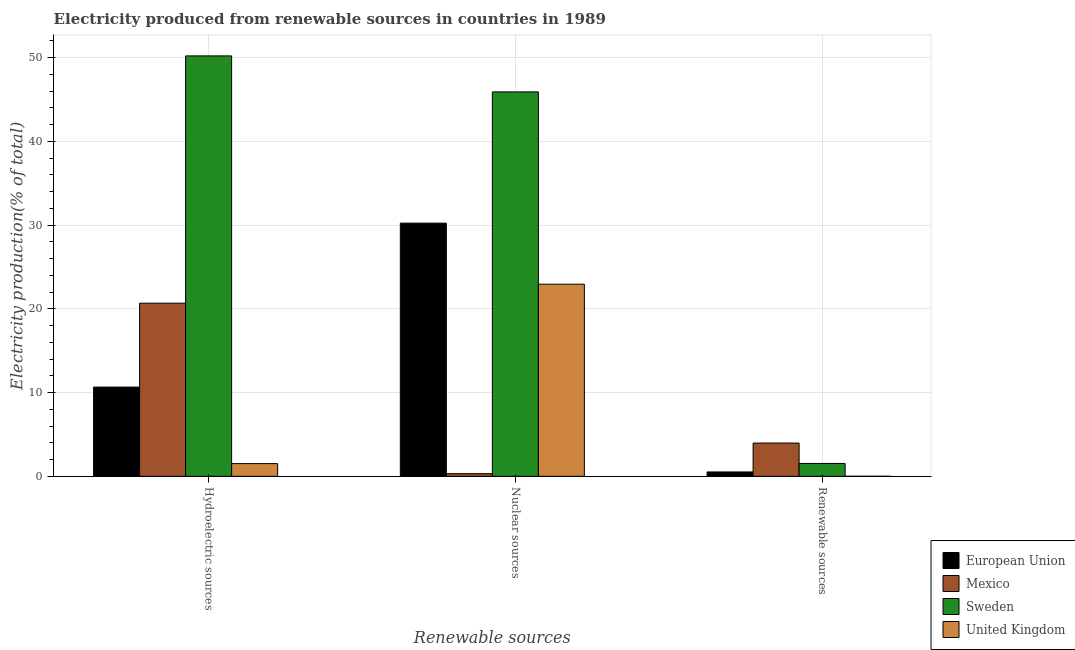How many groups of bars are there?
Provide a succinct answer. 3. Are the number of bars per tick equal to the number of legend labels?
Your answer should be very brief. Yes. Are the number of bars on each tick of the X-axis equal?
Ensure brevity in your answer.  Yes. How many bars are there on the 2nd tick from the right?
Give a very brief answer. 4. What is the label of the 3rd group of bars from the left?
Make the answer very short. Renewable sources. What is the percentage of electricity produced by hydroelectric sources in Sweden?
Give a very brief answer. 50.2. Across all countries, what is the maximum percentage of electricity produced by hydroelectric sources?
Your response must be concise. 50.2. Across all countries, what is the minimum percentage of electricity produced by renewable sources?
Give a very brief answer. 0. In which country was the percentage of electricity produced by hydroelectric sources minimum?
Your response must be concise. United Kingdom. What is the total percentage of electricity produced by renewable sources in the graph?
Your response must be concise. 6.03. What is the difference between the percentage of electricity produced by hydroelectric sources in Sweden and that in United Kingdom?
Your response must be concise. 48.68. What is the difference between the percentage of electricity produced by renewable sources in Sweden and the percentage of electricity produced by hydroelectric sources in Mexico?
Your answer should be compact. -19.14. What is the average percentage of electricity produced by hydroelectric sources per country?
Provide a succinct answer. 20.76. What is the difference between the percentage of electricity produced by nuclear sources and percentage of electricity produced by hydroelectric sources in Mexico?
Provide a succinct answer. -20.36. In how many countries, is the percentage of electricity produced by nuclear sources greater than 6 %?
Make the answer very short. 3. What is the ratio of the percentage of electricity produced by renewable sources in Mexico to that in European Union?
Offer a very short reply. 7.61. What is the difference between the highest and the second highest percentage of electricity produced by hydroelectric sources?
Make the answer very short. 29.53. What is the difference between the highest and the lowest percentage of electricity produced by hydroelectric sources?
Offer a very short reply. 48.68. In how many countries, is the percentage of electricity produced by hydroelectric sources greater than the average percentage of electricity produced by hydroelectric sources taken over all countries?
Your answer should be compact. 1. Is the sum of the percentage of electricity produced by hydroelectric sources in Sweden and Mexico greater than the maximum percentage of electricity produced by nuclear sources across all countries?
Your answer should be compact. Yes. Is it the case that in every country, the sum of the percentage of electricity produced by hydroelectric sources and percentage of electricity produced by nuclear sources is greater than the percentage of electricity produced by renewable sources?
Offer a very short reply. Yes. How many bars are there?
Your response must be concise. 12. How many countries are there in the graph?
Offer a very short reply. 4. What is the difference between two consecutive major ticks on the Y-axis?
Your answer should be very brief. 10. Are the values on the major ticks of Y-axis written in scientific E-notation?
Offer a very short reply. No. Does the graph contain any zero values?
Your response must be concise. No. Does the graph contain grids?
Your answer should be very brief. Yes. How are the legend labels stacked?
Provide a succinct answer. Vertical. What is the title of the graph?
Your answer should be very brief. Electricity produced from renewable sources in countries in 1989. Does "Rwanda" appear as one of the legend labels in the graph?
Your response must be concise. No. What is the label or title of the X-axis?
Keep it short and to the point. Renewable sources. What is the label or title of the Y-axis?
Ensure brevity in your answer.  Electricity production(% of total). What is the Electricity production(% of total) of European Union in Hydroelectric sources?
Provide a succinct answer. 10.66. What is the Electricity production(% of total) in Mexico in Hydroelectric sources?
Make the answer very short. 20.67. What is the Electricity production(% of total) in Sweden in Hydroelectric sources?
Provide a succinct answer. 50.2. What is the Electricity production(% of total) of United Kingdom in Hydroelectric sources?
Make the answer very short. 1.52. What is the Electricity production(% of total) in European Union in Nuclear sources?
Your answer should be very brief. 30.23. What is the Electricity production(% of total) in Mexico in Nuclear sources?
Your answer should be compact. 0.32. What is the Electricity production(% of total) of Sweden in Nuclear sources?
Provide a succinct answer. 45.9. What is the Electricity production(% of total) in United Kingdom in Nuclear sources?
Ensure brevity in your answer.  22.94. What is the Electricity production(% of total) of European Union in Renewable sources?
Your response must be concise. 0.52. What is the Electricity production(% of total) of Mexico in Renewable sources?
Your answer should be very brief. 3.97. What is the Electricity production(% of total) of Sweden in Renewable sources?
Give a very brief answer. 1.54. What is the Electricity production(% of total) of United Kingdom in Renewable sources?
Your answer should be very brief. 0. Across all Renewable sources, what is the maximum Electricity production(% of total) in European Union?
Ensure brevity in your answer.  30.23. Across all Renewable sources, what is the maximum Electricity production(% of total) in Mexico?
Offer a very short reply. 20.67. Across all Renewable sources, what is the maximum Electricity production(% of total) in Sweden?
Make the answer very short. 50.2. Across all Renewable sources, what is the maximum Electricity production(% of total) in United Kingdom?
Your answer should be compact. 22.94. Across all Renewable sources, what is the minimum Electricity production(% of total) in European Union?
Make the answer very short. 0.52. Across all Renewable sources, what is the minimum Electricity production(% of total) in Mexico?
Give a very brief answer. 0.32. Across all Renewable sources, what is the minimum Electricity production(% of total) in Sweden?
Provide a short and direct response. 1.54. Across all Renewable sources, what is the minimum Electricity production(% of total) of United Kingdom?
Give a very brief answer. 0. What is the total Electricity production(% of total) in European Union in the graph?
Provide a short and direct response. 41.41. What is the total Electricity production(% of total) in Mexico in the graph?
Give a very brief answer. 24.96. What is the total Electricity production(% of total) of Sweden in the graph?
Ensure brevity in your answer.  97.64. What is the total Electricity production(% of total) in United Kingdom in the graph?
Your answer should be very brief. 24.46. What is the difference between the Electricity production(% of total) of European Union in Hydroelectric sources and that in Nuclear sources?
Provide a short and direct response. -19.58. What is the difference between the Electricity production(% of total) in Mexico in Hydroelectric sources and that in Nuclear sources?
Offer a very short reply. 20.36. What is the difference between the Electricity production(% of total) of Sweden in Hydroelectric sources and that in Nuclear sources?
Your response must be concise. 4.3. What is the difference between the Electricity production(% of total) of United Kingdom in Hydroelectric sources and that in Nuclear sources?
Offer a very short reply. -21.42. What is the difference between the Electricity production(% of total) in European Union in Hydroelectric sources and that in Renewable sources?
Offer a terse response. 10.13. What is the difference between the Electricity production(% of total) in Mexico in Hydroelectric sources and that in Renewable sources?
Provide a short and direct response. 16.7. What is the difference between the Electricity production(% of total) of Sweden in Hydroelectric sources and that in Renewable sources?
Provide a succinct answer. 48.67. What is the difference between the Electricity production(% of total) in United Kingdom in Hydroelectric sources and that in Renewable sources?
Keep it short and to the point. 1.52. What is the difference between the Electricity production(% of total) of European Union in Nuclear sources and that in Renewable sources?
Your answer should be very brief. 29.71. What is the difference between the Electricity production(% of total) in Mexico in Nuclear sources and that in Renewable sources?
Keep it short and to the point. -3.66. What is the difference between the Electricity production(% of total) in Sweden in Nuclear sources and that in Renewable sources?
Ensure brevity in your answer.  44.37. What is the difference between the Electricity production(% of total) of United Kingdom in Nuclear sources and that in Renewable sources?
Offer a terse response. 22.94. What is the difference between the Electricity production(% of total) in European Union in Hydroelectric sources and the Electricity production(% of total) in Mexico in Nuclear sources?
Ensure brevity in your answer.  10.34. What is the difference between the Electricity production(% of total) of European Union in Hydroelectric sources and the Electricity production(% of total) of Sweden in Nuclear sources?
Provide a short and direct response. -35.25. What is the difference between the Electricity production(% of total) of European Union in Hydroelectric sources and the Electricity production(% of total) of United Kingdom in Nuclear sources?
Your answer should be very brief. -12.29. What is the difference between the Electricity production(% of total) in Mexico in Hydroelectric sources and the Electricity production(% of total) in Sweden in Nuclear sources?
Offer a terse response. -25.23. What is the difference between the Electricity production(% of total) in Mexico in Hydroelectric sources and the Electricity production(% of total) in United Kingdom in Nuclear sources?
Ensure brevity in your answer.  -2.27. What is the difference between the Electricity production(% of total) in Sweden in Hydroelectric sources and the Electricity production(% of total) in United Kingdom in Nuclear sources?
Your answer should be very brief. 27.26. What is the difference between the Electricity production(% of total) in European Union in Hydroelectric sources and the Electricity production(% of total) in Mexico in Renewable sources?
Your answer should be compact. 6.68. What is the difference between the Electricity production(% of total) of European Union in Hydroelectric sources and the Electricity production(% of total) of Sweden in Renewable sources?
Offer a very short reply. 9.12. What is the difference between the Electricity production(% of total) of European Union in Hydroelectric sources and the Electricity production(% of total) of United Kingdom in Renewable sources?
Your answer should be compact. 10.65. What is the difference between the Electricity production(% of total) in Mexico in Hydroelectric sources and the Electricity production(% of total) in Sweden in Renewable sources?
Your response must be concise. 19.14. What is the difference between the Electricity production(% of total) in Mexico in Hydroelectric sources and the Electricity production(% of total) in United Kingdom in Renewable sources?
Your response must be concise. 20.67. What is the difference between the Electricity production(% of total) in Sweden in Hydroelectric sources and the Electricity production(% of total) in United Kingdom in Renewable sources?
Give a very brief answer. 50.2. What is the difference between the Electricity production(% of total) in European Union in Nuclear sources and the Electricity production(% of total) in Mexico in Renewable sources?
Give a very brief answer. 26.26. What is the difference between the Electricity production(% of total) of European Union in Nuclear sources and the Electricity production(% of total) of Sweden in Renewable sources?
Your answer should be compact. 28.7. What is the difference between the Electricity production(% of total) in European Union in Nuclear sources and the Electricity production(% of total) in United Kingdom in Renewable sources?
Ensure brevity in your answer.  30.23. What is the difference between the Electricity production(% of total) in Mexico in Nuclear sources and the Electricity production(% of total) in Sweden in Renewable sources?
Make the answer very short. -1.22. What is the difference between the Electricity production(% of total) of Mexico in Nuclear sources and the Electricity production(% of total) of United Kingdom in Renewable sources?
Provide a short and direct response. 0.31. What is the difference between the Electricity production(% of total) in Sweden in Nuclear sources and the Electricity production(% of total) in United Kingdom in Renewable sources?
Your response must be concise. 45.9. What is the average Electricity production(% of total) in European Union per Renewable sources?
Provide a short and direct response. 13.8. What is the average Electricity production(% of total) in Mexico per Renewable sources?
Offer a terse response. 8.32. What is the average Electricity production(% of total) in Sweden per Renewable sources?
Ensure brevity in your answer.  32.55. What is the average Electricity production(% of total) of United Kingdom per Renewable sources?
Your answer should be very brief. 8.15. What is the difference between the Electricity production(% of total) of European Union and Electricity production(% of total) of Mexico in Hydroelectric sources?
Provide a succinct answer. -10.02. What is the difference between the Electricity production(% of total) of European Union and Electricity production(% of total) of Sweden in Hydroelectric sources?
Provide a succinct answer. -39.55. What is the difference between the Electricity production(% of total) in European Union and Electricity production(% of total) in United Kingdom in Hydroelectric sources?
Provide a short and direct response. 9.14. What is the difference between the Electricity production(% of total) of Mexico and Electricity production(% of total) of Sweden in Hydroelectric sources?
Provide a short and direct response. -29.53. What is the difference between the Electricity production(% of total) of Mexico and Electricity production(% of total) of United Kingdom in Hydroelectric sources?
Your answer should be very brief. 19.15. What is the difference between the Electricity production(% of total) in Sweden and Electricity production(% of total) in United Kingdom in Hydroelectric sources?
Your answer should be compact. 48.68. What is the difference between the Electricity production(% of total) in European Union and Electricity production(% of total) in Mexico in Nuclear sources?
Ensure brevity in your answer.  29.91. What is the difference between the Electricity production(% of total) of European Union and Electricity production(% of total) of Sweden in Nuclear sources?
Your answer should be very brief. -15.67. What is the difference between the Electricity production(% of total) of European Union and Electricity production(% of total) of United Kingdom in Nuclear sources?
Your response must be concise. 7.29. What is the difference between the Electricity production(% of total) of Mexico and Electricity production(% of total) of Sweden in Nuclear sources?
Your answer should be compact. -45.59. What is the difference between the Electricity production(% of total) of Mexico and Electricity production(% of total) of United Kingdom in Nuclear sources?
Make the answer very short. -22.63. What is the difference between the Electricity production(% of total) in Sweden and Electricity production(% of total) in United Kingdom in Nuclear sources?
Make the answer very short. 22.96. What is the difference between the Electricity production(% of total) in European Union and Electricity production(% of total) in Mexico in Renewable sources?
Make the answer very short. -3.45. What is the difference between the Electricity production(% of total) of European Union and Electricity production(% of total) of Sweden in Renewable sources?
Offer a terse response. -1.01. What is the difference between the Electricity production(% of total) in European Union and Electricity production(% of total) in United Kingdom in Renewable sources?
Keep it short and to the point. 0.52. What is the difference between the Electricity production(% of total) in Mexico and Electricity production(% of total) in Sweden in Renewable sources?
Your answer should be compact. 2.44. What is the difference between the Electricity production(% of total) of Mexico and Electricity production(% of total) of United Kingdom in Renewable sources?
Make the answer very short. 3.97. What is the difference between the Electricity production(% of total) in Sweden and Electricity production(% of total) in United Kingdom in Renewable sources?
Keep it short and to the point. 1.53. What is the ratio of the Electricity production(% of total) in European Union in Hydroelectric sources to that in Nuclear sources?
Ensure brevity in your answer.  0.35. What is the ratio of the Electricity production(% of total) of Mexico in Hydroelectric sources to that in Nuclear sources?
Ensure brevity in your answer.  65.41. What is the ratio of the Electricity production(% of total) in Sweden in Hydroelectric sources to that in Nuclear sources?
Give a very brief answer. 1.09. What is the ratio of the Electricity production(% of total) in United Kingdom in Hydroelectric sources to that in Nuclear sources?
Your answer should be compact. 0.07. What is the ratio of the Electricity production(% of total) in European Union in Hydroelectric sources to that in Renewable sources?
Provide a succinct answer. 20.41. What is the ratio of the Electricity production(% of total) in Mexico in Hydroelectric sources to that in Renewable sources?
Your answer should be very brief. 5.2. What is the ratio of the Electricity production(% of total) in Sweden in Hydroelectric sources to that in Renewable sources?
Make the answer very short. 32.7. What is the ratio of the Electricity production(% of total) of United Kingdom in Hydroelectric sources to that in Renewable sources?
Keep it short and to the point. 527.67. What is the ratio of the Electricity production(% of total) of European Union in Nuclear sources to that in Renewable sources?
Your answer should be compact. 57.92. What is the ratio of the Electricity production(% of total) of Mexico in Nuclear sources to that in Renewable sources?
Your response must be concise. 0.08. What is the ratio of the Electricity production(% of total) of Sweden in Nuclear sources to that in Renewable sources?
Give a very brief answer. 29.9. What is the ratio of the Electricity production(% of total) in United Kingdom in Nuclear sources to that in Renewable sources?
Your answer should be very brief. 7970.44. What is the difference between the highest and the second highest Electricity production(% of total) in European Union?
Your response must be concise. 19.58. What is the difference between the highest and the second highest Electricity production(% of total) in Mexico?
Make the answer very short. 16.7. What is the difference between the highest and the second highest Electricity production(% of total) in Sweden?
Ensure brevity in your answer.  4.3. What is the difference between the highest and the second highest Electricity production(% of total) of United Kingdom?
Your response must be concise. 21.42. What is the difference between the highest and the lowest Electricity production(% of total) of European Union?
Your response must be concise. 29.71. What is the difference between the highest and the lowest Electricity production(% of total) in Mexico?
Provide a short and direct response. 20.36. What is the difference between the highest and the lowest Electricity production(% of total) of Sweden?
Your answer should be very brief. 48.67. What is the difference between the highest and the lowest Electricity production(% of total) in United Kingdom?
Provide a succinct answer. 22.94. 